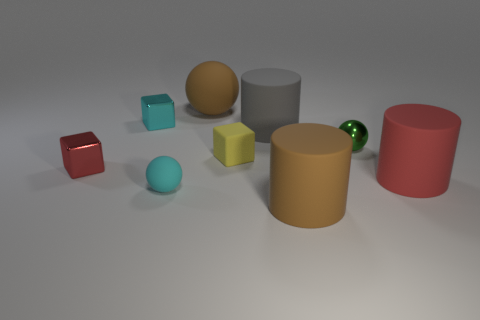Subtract all rubber spheres. How many spheres are left? 1 Subtract all red cubes. How many cubes are left? 2 Add 1 large blue shiny cylinders. How many objects exist? 10 Subtract 3 blocks. How many blocks are left? 0 Subtract all brown cylinders. Subtract all yellow blocks. How many cylinders are left? 2 Subtract all cyan cylinders. How many cyan balls are left? 1 Subtract all large cyan shiny cubes. Subtract all large brown matte spheres. How many objects are left? 8 Add 6 metal things. How many metal things are left? 9 Add 2 brown matte things. How many brown matte things exist? 4 Subtract 0 green cylinders. How many objects are left? 9 